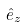Convert formula to latex. <formula><loc_0><loc_0><loc_500><loc_500>\hat { e } _ { z }</formula> 